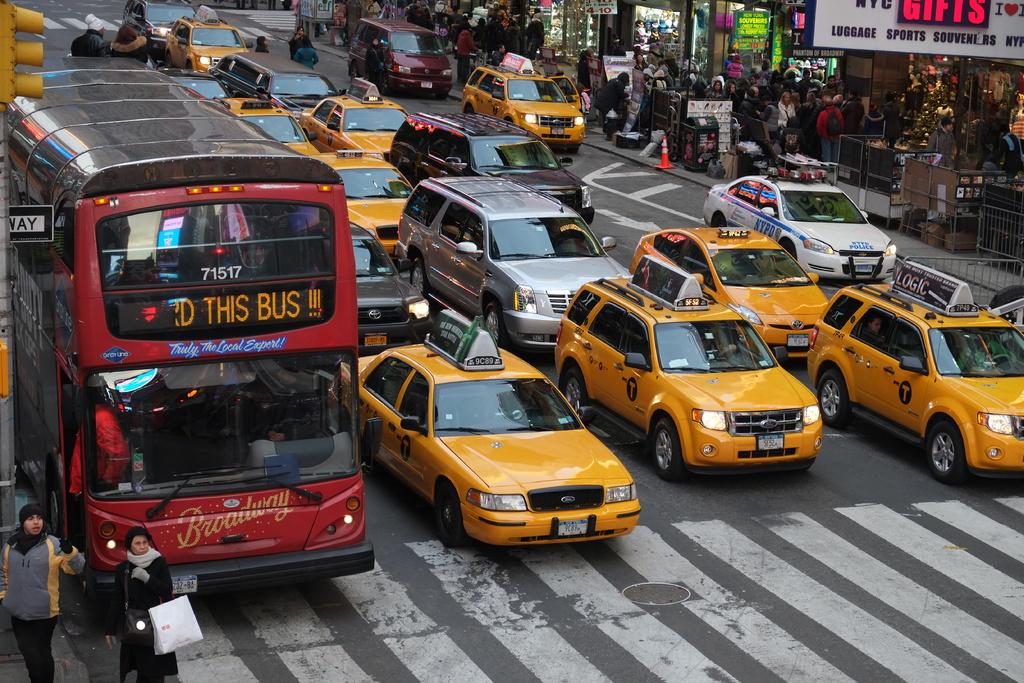What show is advertised on the bus?
Provide a succinct answer. Broadway. What is the bus number?
Make the answer very short. 71517. 